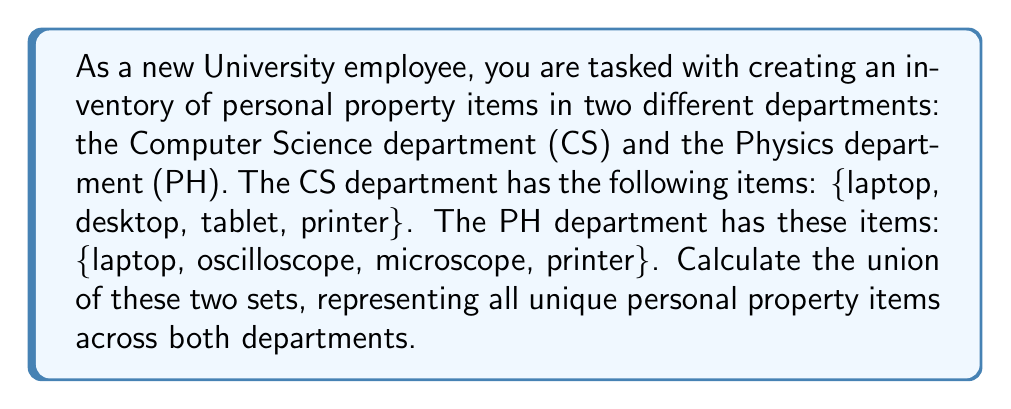Solve this math problem. To solve this problem, we need to understand the concept of union in set theory. The union of two sets A and B, denoted as $A \cup B$, is the set of all elements that are in A, or in B, or in both A and B.

Let's define our sets:
$$CS = \{laptop, desktop, tablet, printer\}$$
$$PH = \{laptop, oscilloscope, microscope, printer\}$$

To find the union $CS \cup PH$, we list all unique elements from both sets:

1. Start with all elements from CS: 
   $\{laptop, desktop, tablet, printer\}$

2. Add any elements from PH that are not already in the set:
   - laptop: already included
   - oscilloscope: add to the set
   - microscope: add to the set
   - printer: already included

Therefore, the union of CS and PH is:
$$CS \cup PH = \{laptop, desktop, tablet, printer, oscilloscope, microscope\}$$

Note that laptop and printer appear only once in the union, even though they are present in both original sets.
Answer: $CS \cup PH = \{laptop, desktop, tablet, printer, oscilloscope, microscope\}$ 